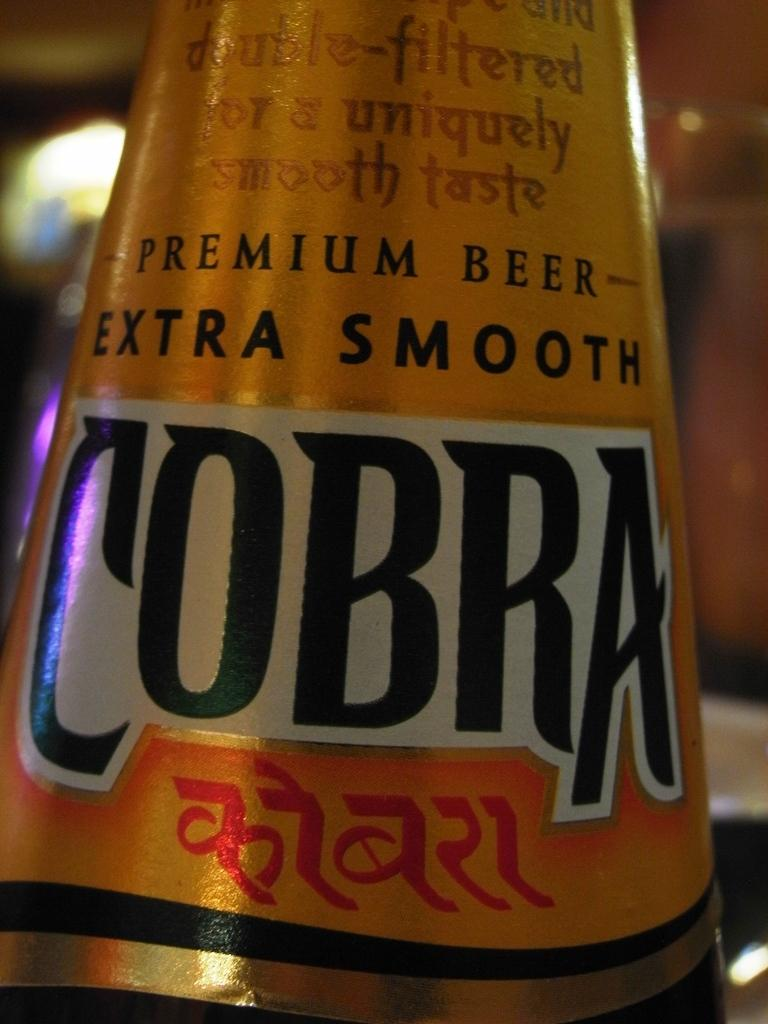<image>
Render a clear and concise summary of the photo. the neck of premium beer- extra smooth cobra 